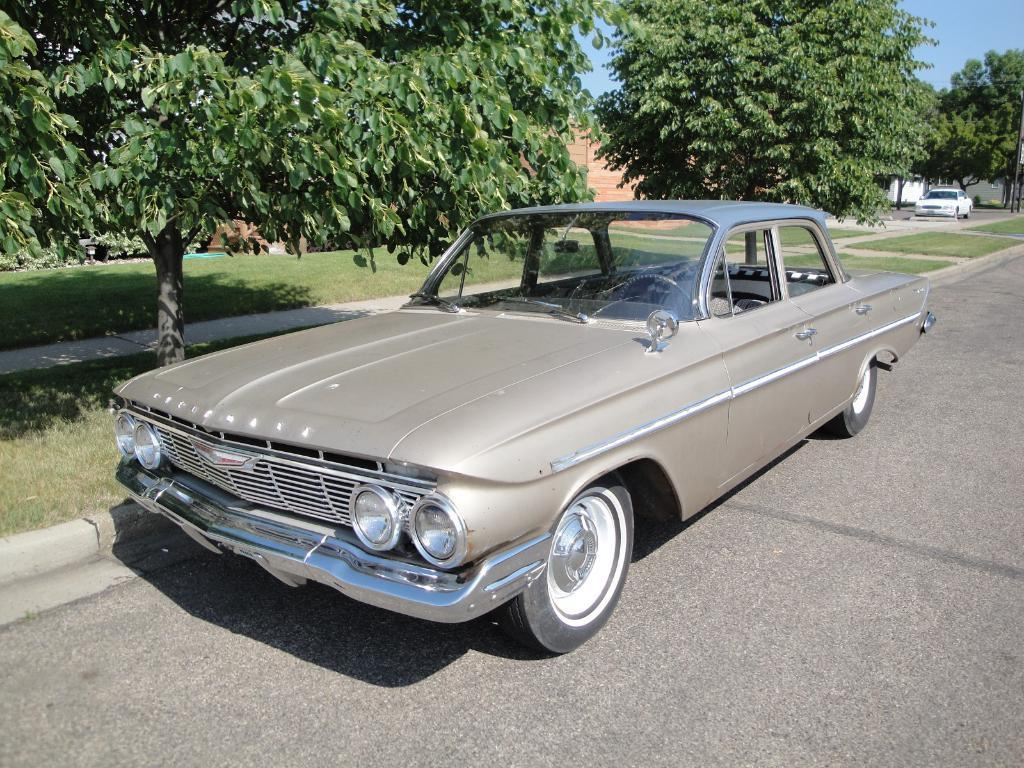What is the main subject of the image? There is a car on the road in the image. What type of natural environment is visible in the image? There is grass and trees visible in the image. What can be seen in the background of the image? There are walls and the sky visible in the background of the image. What type of suit is the car wearing in the image? Cars do not wear suits; the question is not applicable to the image. 